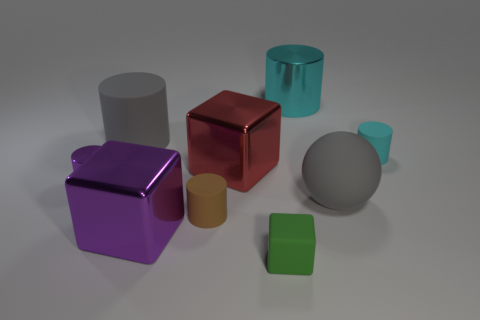The small object in front of the matte cylinder that is in front of the big gray rubber thing in front of the red shiny block is made of what material?
Provide a succinct answer. Rubber. The sphere has what color?
Your response must be concise. Gray. What number of small objects are gray cylinders or brown cylinders?
Your answer should be very brief. 1. What is the material of the large thing that is the same color as the big ball?
Ensure brevity in your answer.  Rubber. Is the gray thing that is right of the big purple metal block made of the same material as the small cyan thing on the right side of the large gray rubber cylinder?
Ensure brevity in your answer.  Yes. Are there any red things?
Offer a terse response. Yes. Is the number of rubber cylinders to the right of the large gray cylinder greater than the number of cyan cylinders that are right of the big cyan shiny cylinder?
Your answer should be compact. Yes. There is a green object that is the same shape as the big purple thing; what is it made of?
Your response must be concise. Rubber. Is the color of the metallic cylinder that is right of the rubber cube the same as the large metal block that is behind the rubber ball?
Your response must be concise. No. There is a cyan metallic object; what shape is it?
Your answer should be very brief. Cylinder. 